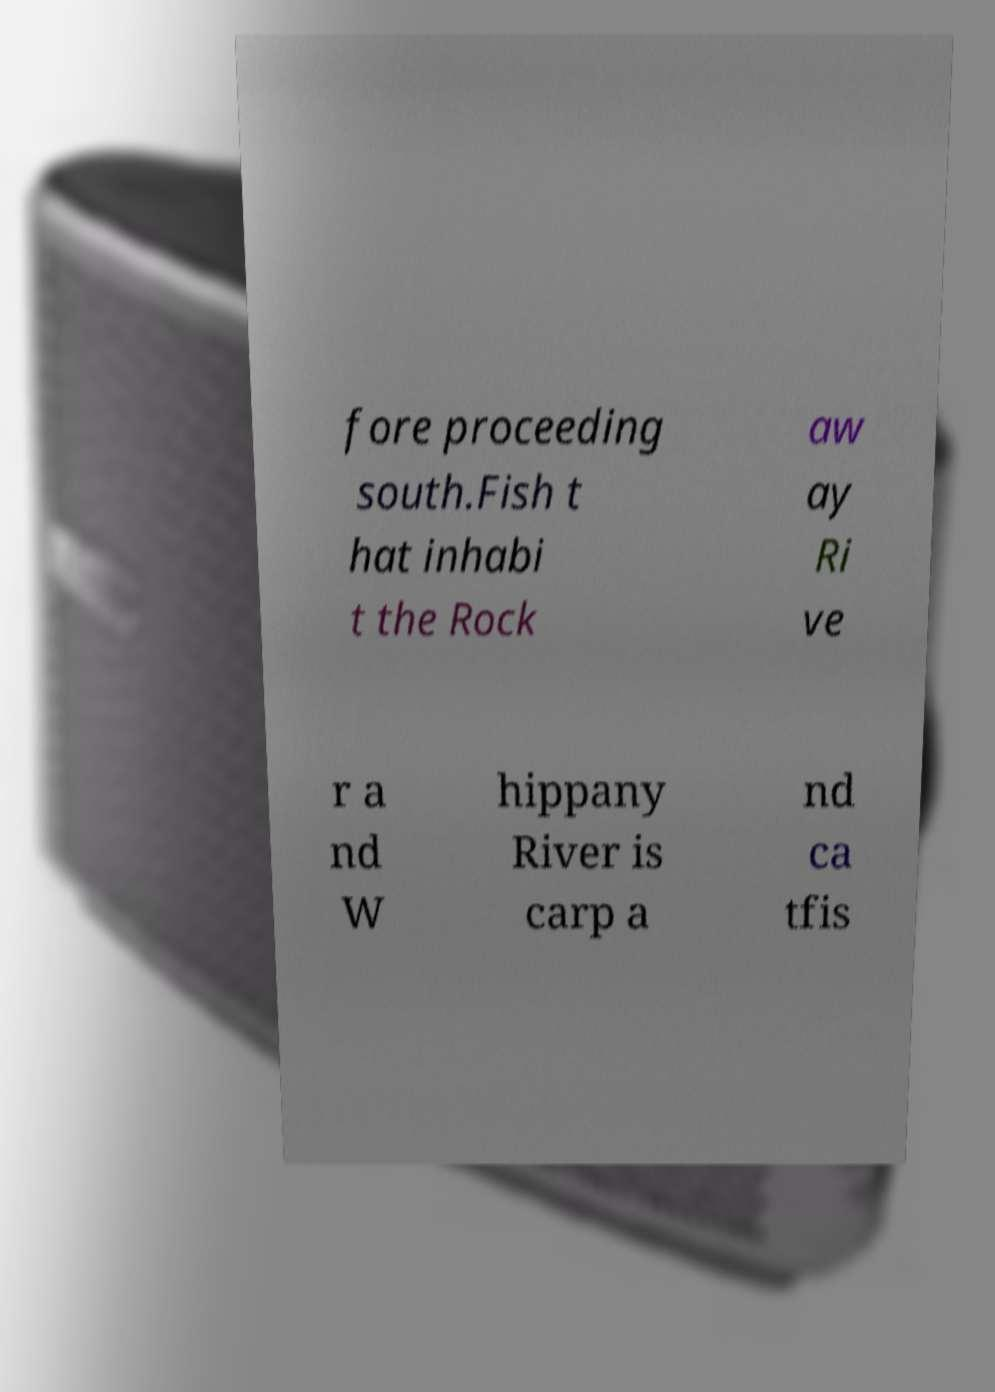I need the written content from this picture converted into text. Can you do that? fore proceeding south.Fish t hat inhabi t the Rock aw ay Ri ve r a nd W hippany River is carp a nd ca tfis 